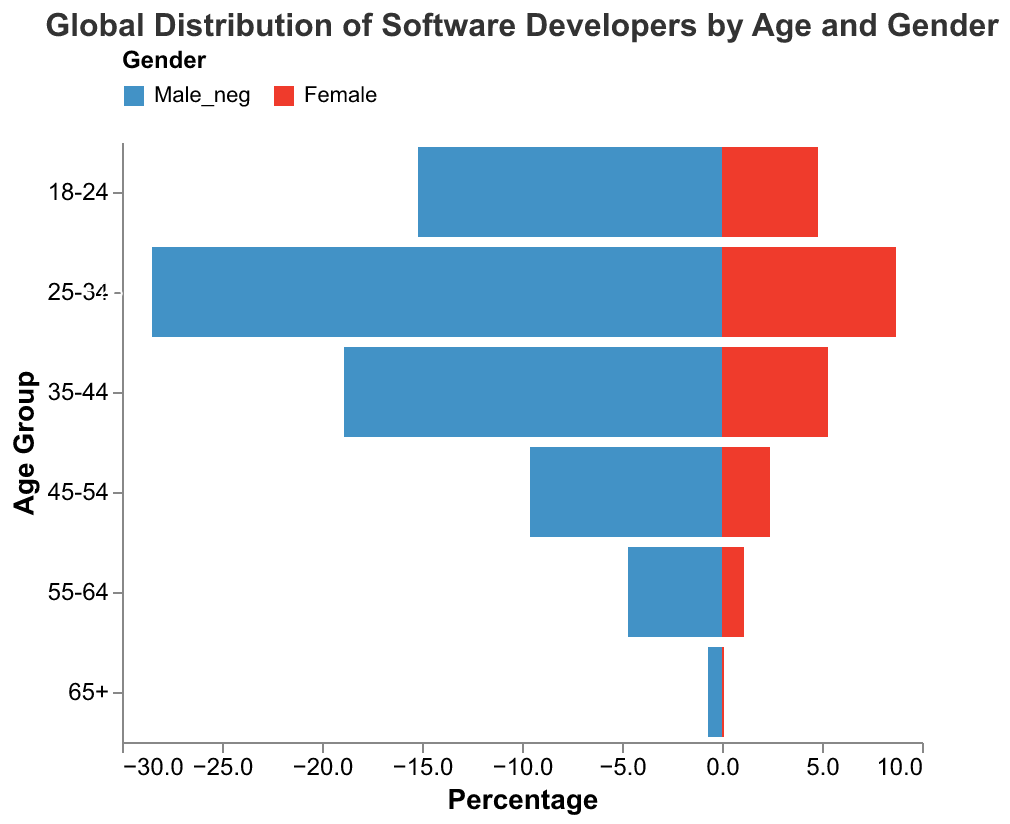Which age group has the highest percentage of male software developers? The bar representing the age group 25-34 has the maximum extension to the left, indicating the highest percentage of male software developers.
Answer: 25-34 What is the total percentage of software developers in the age group 45-54? Add the male and female percentages for the age group 45-54, which are 9.6% and 2.4% respectively. So, 9.6 + 2.4 equals 12.0.
Answer: 12.0% Which gender has a higher percentage in the age group 55-64? Compare the lengths of the bars for males and females in the age group 55-64. The male bar (4.7%) is longer than the female bar (1.1%).
Answer: Male How does the percentage of female developers in the age group 35-44 compare to the percentage of female developers in the age group 45-54? The percentage of female developers in the age group 35-44 is 5.3%, while in the age group 45-54, it is 2.4%. Since 5.3 is greater than 2.4, the percentage of female developers is higher in the 35-44 age group.
Answer: Higher in 35-44 What is the difference in the percentage of male and female software developers in the age group 18-24? Subtract the percentage of female developers from that of male developers in the 18-24 age group: 15.2 - 4.8 equals 10.4.
Answer: 10.4% Which age group has the lowest percentage of software developers overall? Sum the male and female percentages for each age group and identify the smallest sum. The age group 65+ has the sum of 0.7% + 0.1% = 0.8%, which is the smallest.
Answer: 65+ What percentage of global software developers are female and in the age group 25-34? Refer to the bar for female developers in the age group 25-34; the shown percentage is 8.7%.
Answer: 8.7% What is the average percentage of male developers in the age groups 18-24, 25-34, and 35-44? Calculate the average by summing the percentages and dividing by the number of age groups: (15.2 + 28.5 + 18.9) / 3 = 62.6 / 3 = 20.87.
Answer: 20.87% Across all age groups, what is the range of the percentage values for female developers? Identify the smallest and largest percentages for female developers: 0.1% (65+) to 8.7% (25-34). The range is 8.7 - 0.1 = 8.6.
Answer: 8.6 